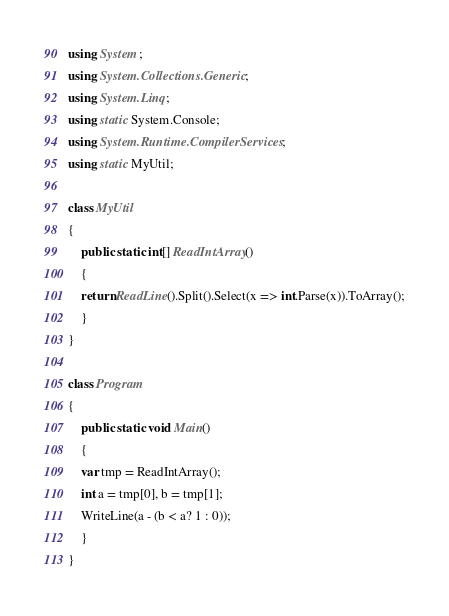<code> <loc_0><loc_0><loc_500><loc_500><_C#_>using System;
using System.Collections.Generic;
using System.Linq;
using static System.Console;
using System.Runtime.CompilerServices;
using static MyUtil;

class MyUtil
{
    public static int[] ReadIntArray()
    {
	return ReadLine().Split().Select(x => int.Parse(x)).ToArray();
    }
}

class Program
{
    public static void Main()
    {
	var tmp = ReadIntArray();
	int a = tmp[0], b = tmp[1];
	WriteLine(a - (b < a? 1 : 0));
    }
}
</code> 